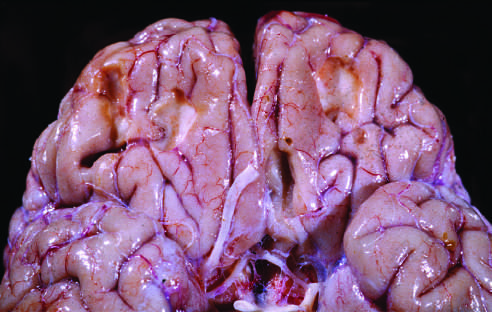re remote contusions, seen as discolored yellow areas, present on the inferior frontal surface of this brain?
Answer the question using a single word or phrase. Yes 